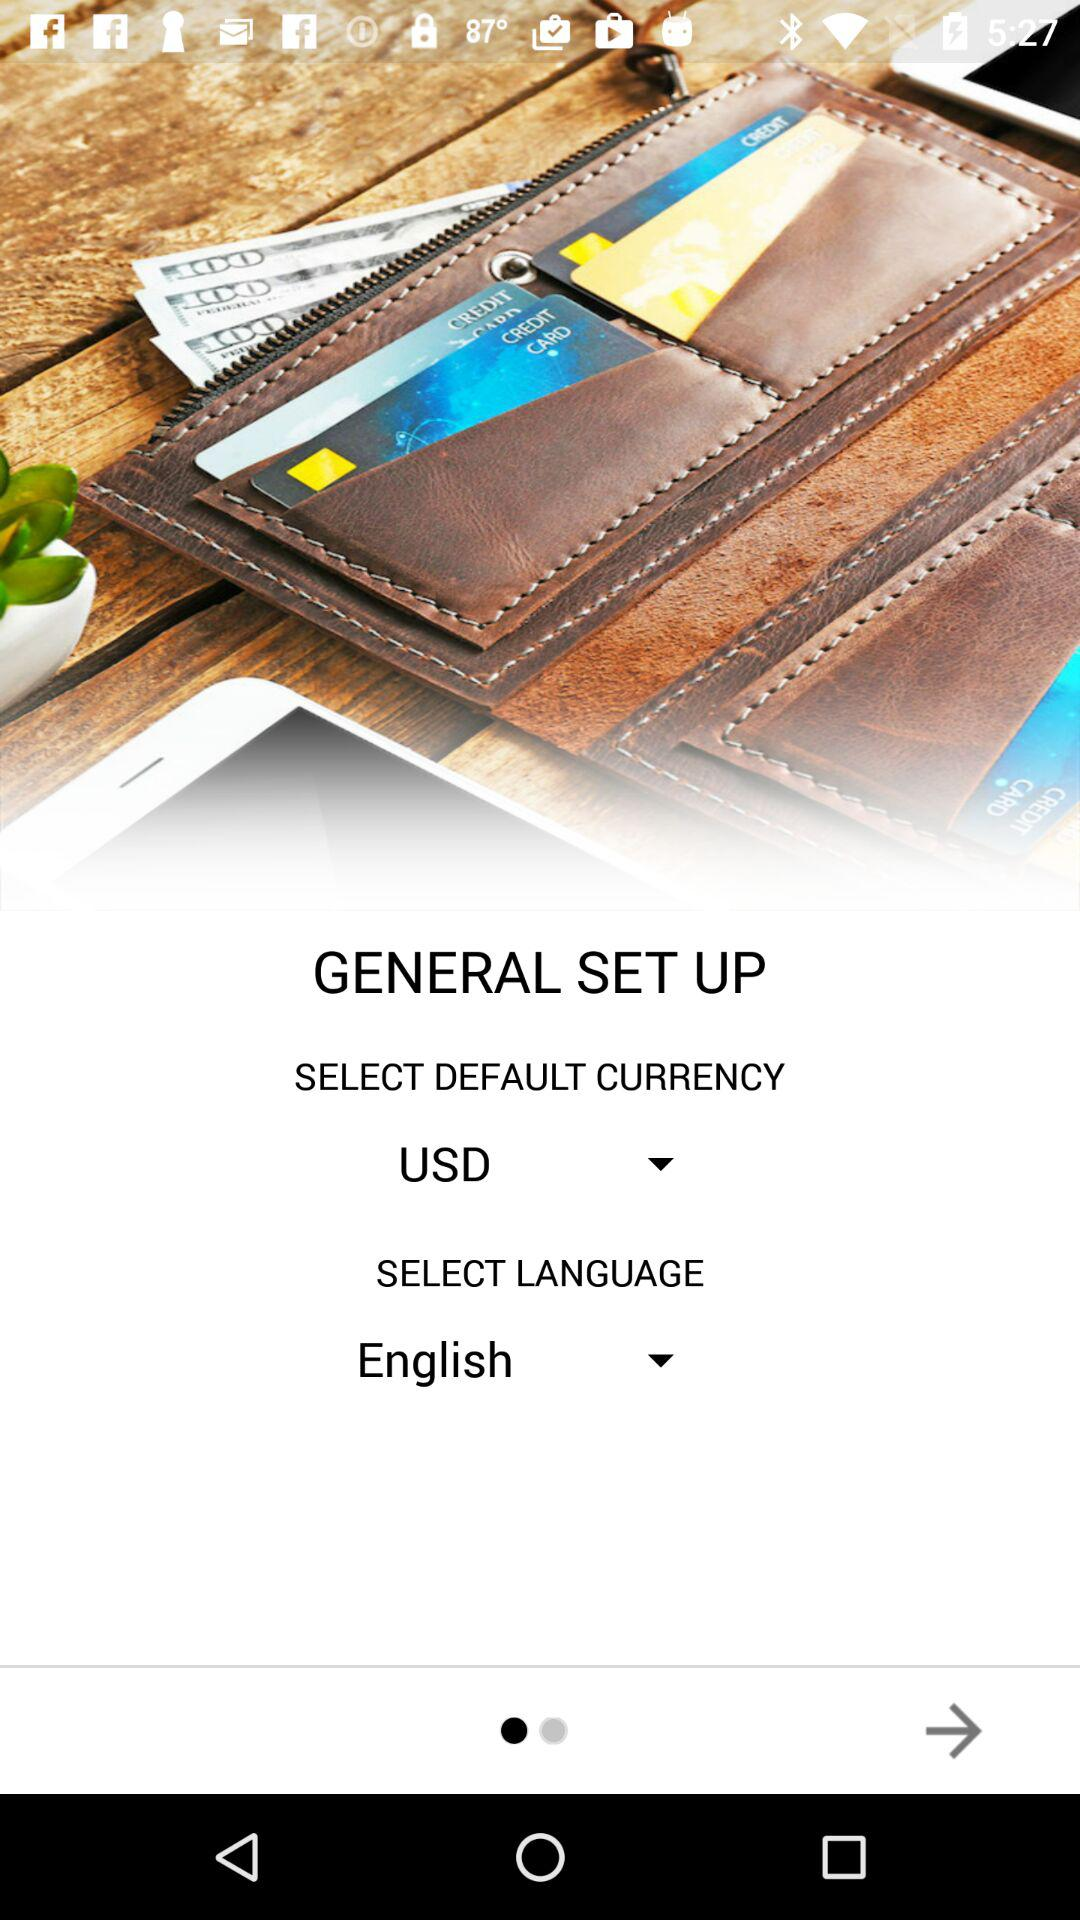What is the selected default currency? The selected default currency is the United States dollar. 